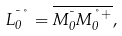<formula> <loc_0><loc_0><loc_500><loc_500>L _ { 0 } ^ { \mu \nu } = \overline { M _ { 0 } ^ { \mu } M _ { 0 } ^ { \nu + } } ,</formula> 